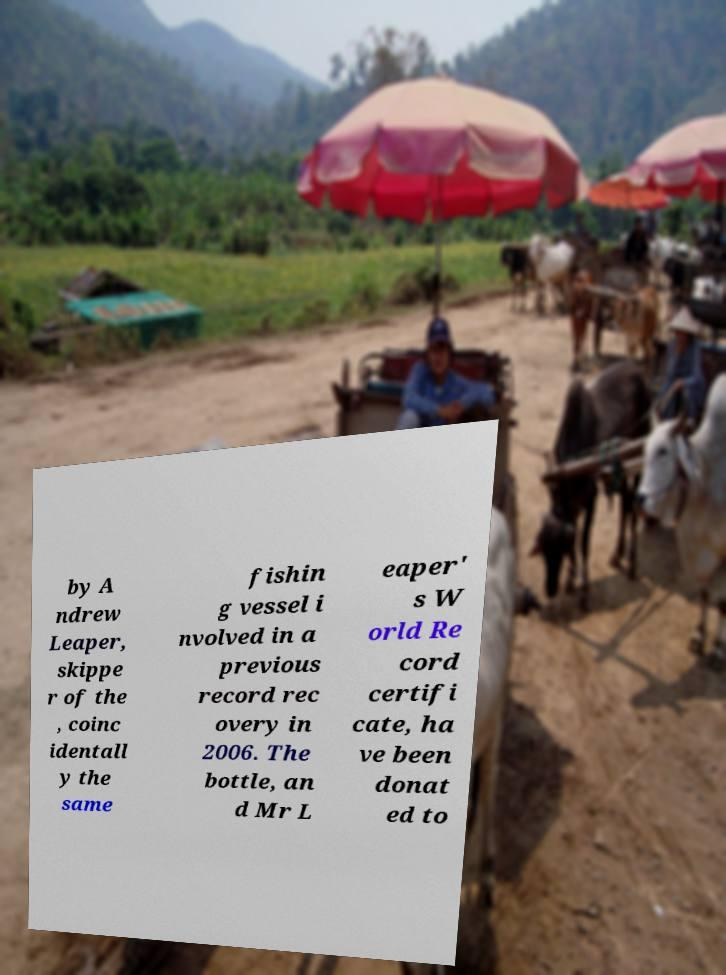Please identify and transcribe the text found in this image. by A ndrew Leaper, skippe r of the , coinc identall y the same fishin g vessel i nvolved in a previous record rec overy in 2006. The bottle, an d Mr L eaper' s W orld Re cord certifi cate, ha ve been donat ed to 